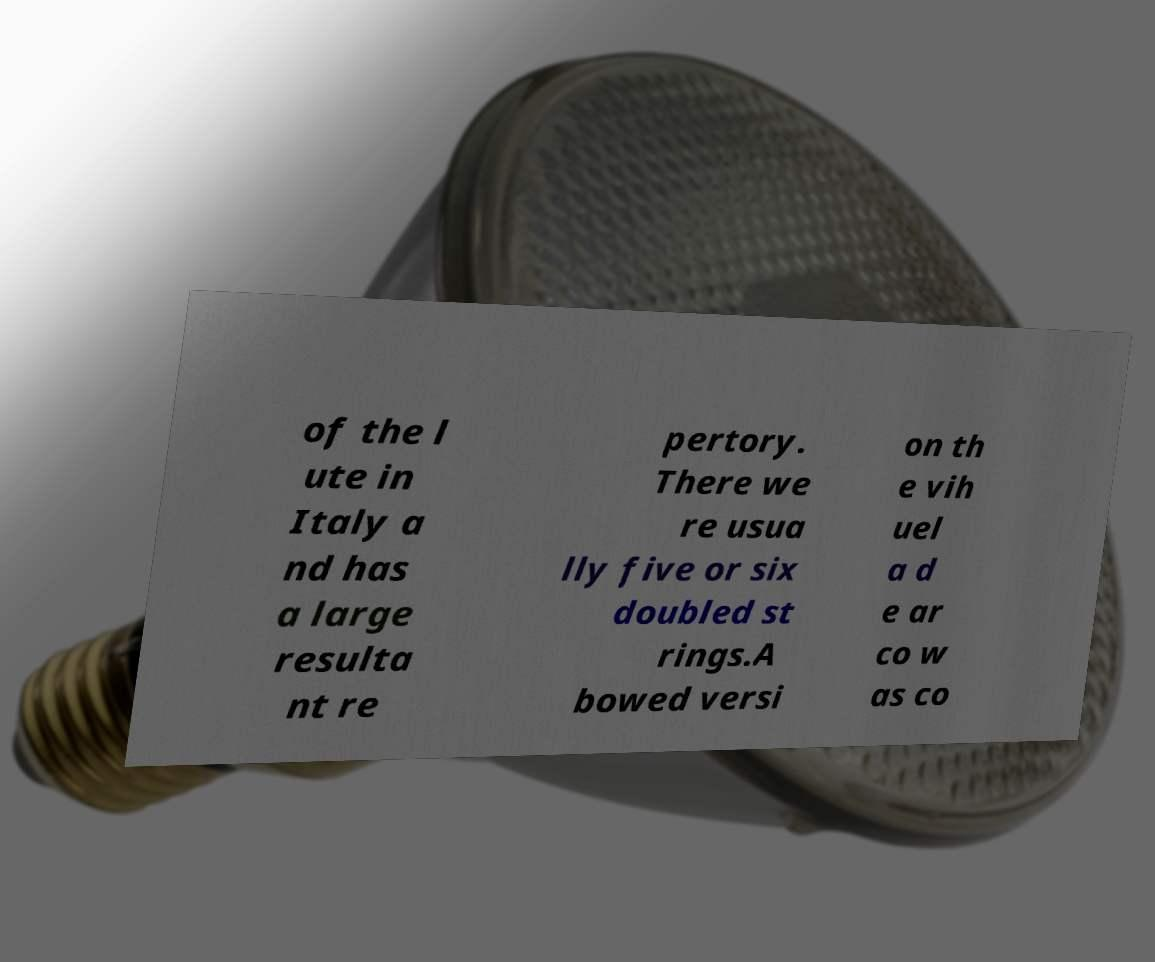What messages or text are displayed in this image? I need them in a readable, typed format. of the l ute in Italy a nd has a large resulta nt re pertory. There we re usua lly five or six doubled st rings.A bowed versi on th e vih uel a d e ar co w as co 